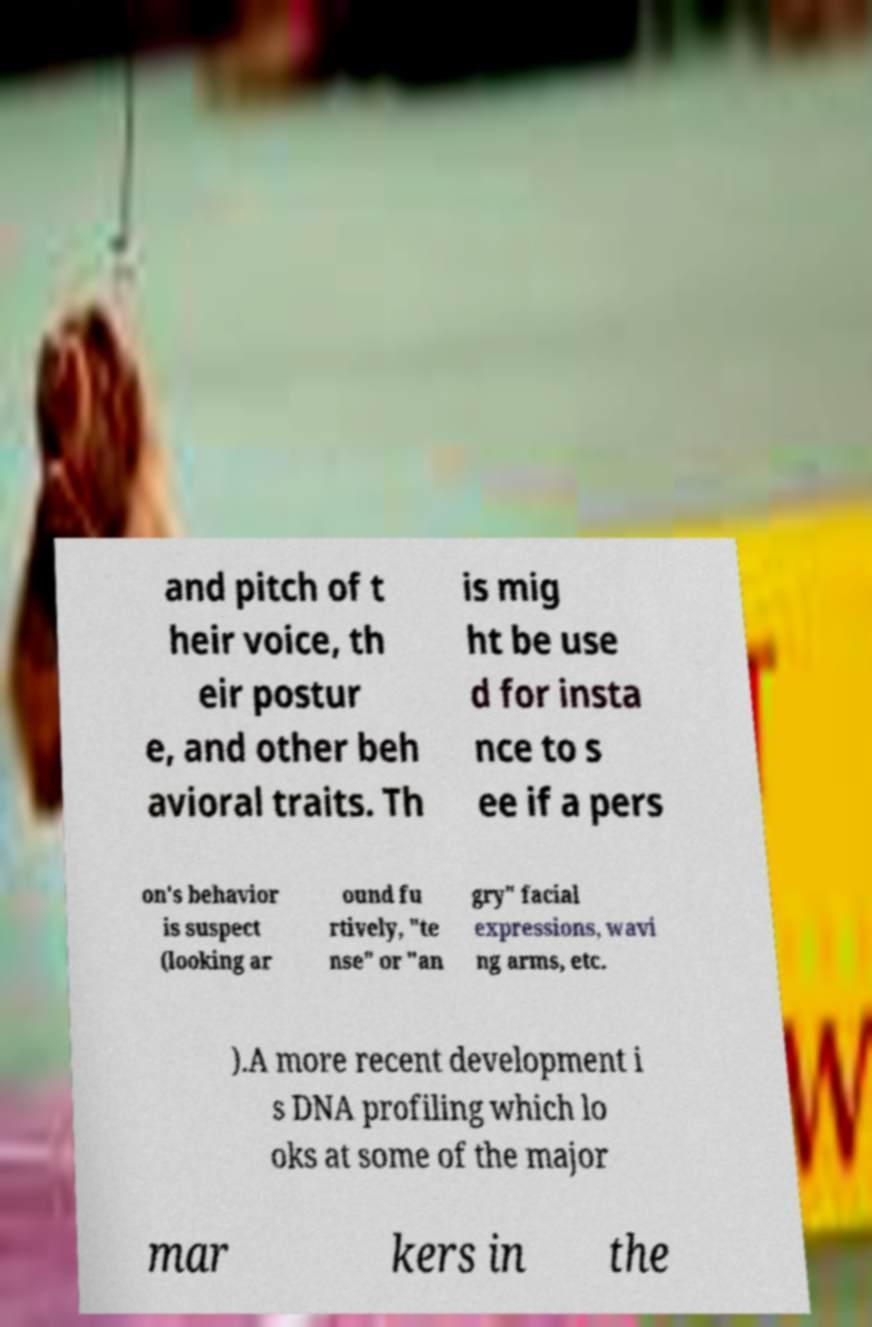Can you read and provide the text displayed in the image?This photo seems to have some interesting text. Can you extract and type it out for me? and pitch of t heir voice, th eir postur e, and other beh avioral traits. Th is mig ht be use d for insta nce to s ee if a pers on's behavior is suspect (looking ar ound fu rtively, "te nse" or "an gry" facial expressions, wavi ng arms, etc. ).A more recent development i s DNA profiling which lo oks at some of the major mar kers in the 